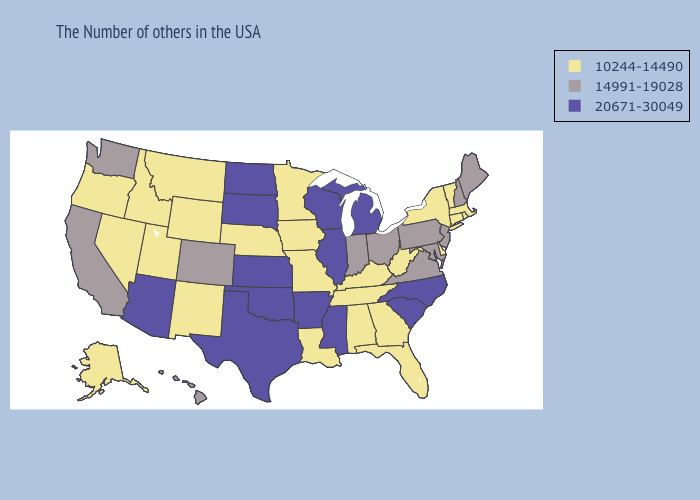Name the states that have a value in the range 20671-30049?
Write a very short answer. North Carolina, South Carolina, Michigan, Wisconsin, Illinois, Mississippi, Arkansas, Kansas, Oklahoma, Texas, South Dakota, North Dakota, Arizona. Does Idaho have the lowest value in the USA?
Concise answer only. Yes. Does Texas have the same value as Florida?
Concise answer only. No. Does Alaska have the lowest value in the USA?
Answer briefly. Yes. Name the states that have a value in the range 20671-30049?
Be succinct. North Carolina, South Carolina, Michigan, Wisconsin, Illinois, Mississippi, Arkansas, Kansas, Oklahoma, Texas, South Dakota, North Dakota, Arizona. What is the value of Louisiana?
Answer briefly. 10244-14490. Does Utah have the highest value in the West?
Quick response, please. No. What is the value of Ohio?
Quick response, please. 14991-19028. Does North Dakota have a higher value than Nebraska?
Keep it brief. Yes. Does New Jersey have the lowest value in the USA?
Keep it brief. No. Does Massachusetts have the highest value in the Northeast?
Answer briefly. No. Does Illinois have the highest value in the USA?
Answer briefly. Yes. Which states hav the highest value in the South?
Keep it brief. North Carolina, South Carolina, Mississippi, Arkansas, Oklahoma, Texas. What is the value of Maryland?
Answer briefly. 14991-19028. 